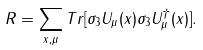<formula> <loc_0><loc_0><loc_500><loc_500>R = \sum _ { x , \mu } T r [ \sigma _ { 3 } U _ { \mu } ( x ) \sigma _ { 3 } U _ { \mu } ^ { \dagger } ( x ) ] .</formula> 